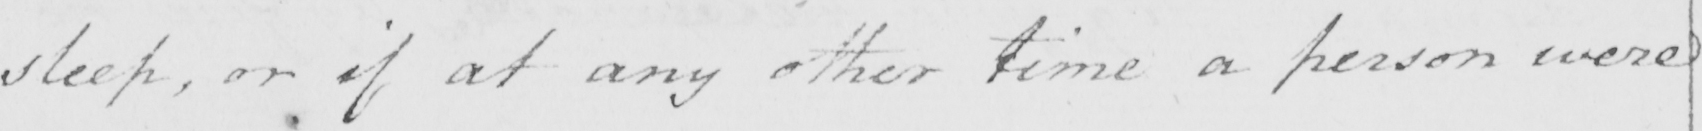What does this handwritten line say? sleep , or if at any other time a person were 